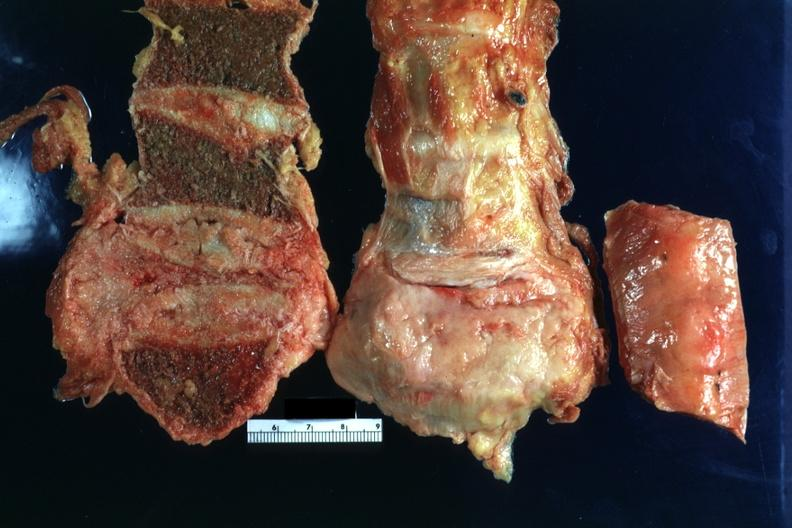does this image show collapsed vertebral body with obvious gray tumor tissue adjacent?
Answer the question using a single word or phrase. Yes 